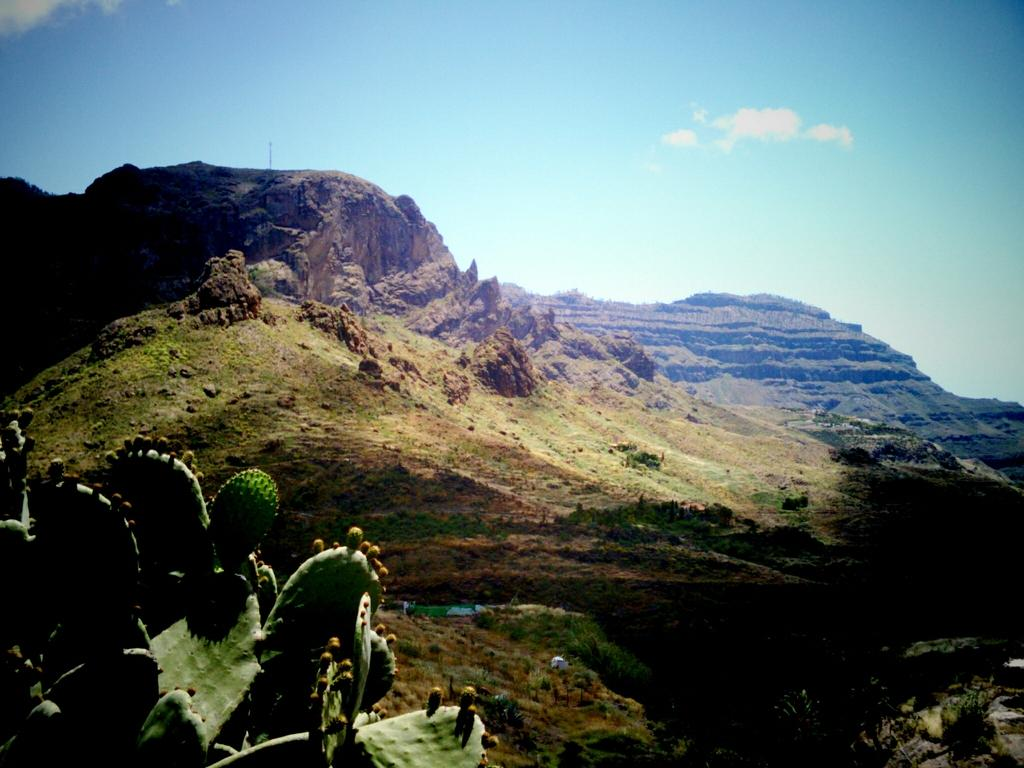What type of vegetation is on the left side of the image? There are plants on the left side of the image. What other types of vegetation can be seen in the image? There are trees in the image. What is covering the ground in the image? There is grass on the ground in the image. What can be seen in the background of the image? There are hills visible in the background of the image, and the sky is also visible. What is the condition of the sky in the image? Clouds are present in the sky. Can you touch the street in the image? There is no street present in the image; it features plants, trees, grass, hills, and the sky. What town is visible in the image? There is no town visible in the image; it is a natural landscape featuring plants, trees, grass, hills, and the sky. 